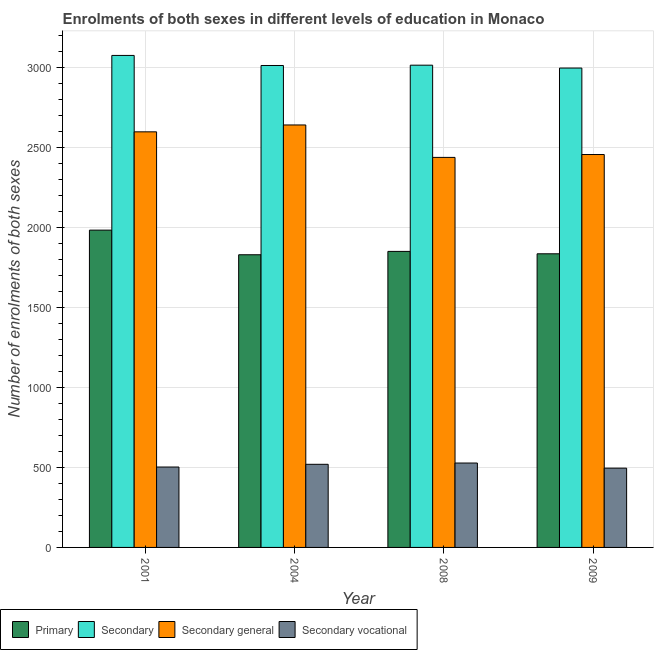How many different coloured bars are there?
Offer a terse response. 4. Are the number of bars per tick equal to the number of legend labels?
Keep it short and to the point. Yes. How many bars are there on the 3rd tick from the left?
Provide a short and direct response. 4. How many bars are there on the 2nd tick from the right?
Make the answer very short. 4. What is the label of the 2nd group of bars from the left?
Make the answer very short. 2004. What is the number of enrolments in secondary education in 2009?
Give a very brief answer. 2999. Across all years, what is the maximum number of enrolments in secondary general education?
Make the answer very short. 2643. Across all years, what is the minimum number of enrolments in secondary vocational education?
Offer a very short reply. 496. In which year was the number of enrolments in secondary general education minimum?
Your answer should be very brief. 2008. What is the total number of enrolments in primary education in the graph?
Offer a very short reply. 7505. What is the difference between the number of enrolments in primary education in 2001 and that in 2008?
Provide a short and direct response. 133. What is the difference between the number of enrolments in secondary vocational education in 2009 and the number of enrolments in secondary general education in 2001?
Give a very brief answer. -7. What is the average number of enrolments in secondary general education per year?
Provide a succinct answer. 2535.25. In the year 2009, what is the difference between the number of enrolments in secondary vocational education and number of enrolments in secondary education?
Offer a terse response. 0. What is the ratio of the number of enrolments in secondary general education in 2004 to that in 2008?
Your response must be concise. 1.08. Is the difference between the number of enrolments in secondary vocational education in 2004 and 2009 greater than the difference between the number of enrolments in secondary education in 2004 and 2009?
Provide a short and direct response. No. What is the difference between the highest and the second highest number of enrolments in primary education?
Provide a succinct answer. 133. What is the difference between the highest and the lowest number of enrolments in secondary vocational education?
Your answer should be very brief. 32. Is the sum of the number of enrolments in secondary vocational education in 2008 and 2009 greater than the maximum number of enrolments in primary education across all years?
Your response must be concise. Yes. What does the 1st bar from the left in 2004 represents?
Your answer should be compact. Primary. What does the 2nd bar from the right in 2001 represents?
Keep it short and to the point. Secondary general. Is it the case that in every year, the sum of the number of enrolments in primary education and number of enrolments in secondary education is greater than the number of enrolments in secondary general education?
Offer a very short reply. Yes. Are all the bars in the graph horizontal?
Make the answer very short. No. How many years are there in the graph?
Offer a very short reply. 4. What is the difference between two consecutive major ticks on the Y-axis?
Keep it short and to the point. 500. Does the graph contain any zero values?
Your answer should be compact. No. What is the title of the graph?
Offer a very short reply. Enrolments of both sexes in different levels of education in Monaco. What is the label or title of the X-axis?
Your response must be concise. Year. What is the label or title of the Y-axis?
Offer a very short reply. Number of enrolments of both sexes. What is the Number of enrolments of both sexes in Primary in 2001?
Provide a short and direct response. 1985. What is the Number of enrolments of both sexes of Secondary in 2001?
Keep it short and to the point. 3078. What is the Number of enrolments of both sexes of Secondary general in 2001?
Offer a terse response. 2600. What is the Number of enrolments of both sexes of Secondary vocational in 2001?
Make the answer very short. 503. What is the Number of enrolments of both sexes of Primary in 2004?
Keep it short and to the point. 1831. What is the Number of enrolments of both sexes of Secondary in 2004?
Offer a very short reply. 3015. What is the Number of enrolments of both sexes of Secondary general in 2004?
Keep it short and to the point. 2643. What is the Number of enrolments of both sexes of Secondary vocational in 2004?
Make the answer very short. 520. What is the Number of enrolments of both sexes of Primary in 2008?
Keep it short and to the point. 1852. What is the Number of enrolments of both sexes in Secondary in 2008?
Your response must be concise. 3017. What is the Number of enrolments of both sexes of Secondary general in 2008?
Ensure brevity in your answer.  2440. What is the Number of enrolments of both sexes of Secondary vocational in 2008?
Your answer should be compact. 528. What is the Number of enrolments of both sexes of Primary in 2009?
Give a very brief answer. 1837. What is the Number of enrolments of both sexes in Secondary in 2009?
Provide a succinct answer. 2999. What is the Number of enrolments of both sexes in Secondary general in 2009?
Your answer should be very brief. 2458. What is the Number of enrolments of both sexes in Secondary vocational in 2009?
Offer a very short reply. 496. Across all years, what is the maximum Number of enrolments of both sexes in Primary?
Ensure brevity in your answer.  1985. Across all years, what is the maximum Number of enrolments of both sexes of Secondary?
Make the answer very short. 3078. Across all years, what is the maximum Number of enrolments of both sexes of Secondary general?
Your response must be concise. 2643. Across all years, what is the maximum Number of enrolments of both sexes in Secondary vocational?
Provide a short and direct response. 528. Across all years, what is the minimum Number of enrolments of both sexes of Primary?
Keep it short and to the point. 1831. Across all years, what is the minimum Number of enrolments of both sexes in Secondary?
Offer a very short reply. 2999. Across all years, what is the minimum Number of enrolments of both sexes of Secondary general?
Give a very brief answer. 2440. Across all years, what is the minimum Number of enrolments of both sexes in Secondary vocational?
Ensure brevity in your answer.  496. What is the total Number of enrolments of both sexes in Primary in the graph?
Make the answer very short. 7505. What is the total Number of enrolments of both sexes of Secondary in the graph?
Provide a short and direct response. 1.21e+04. What is the total Number of enrolments of both sexes of Secondary general in the graph?
Offer a terse response. 1.01e+04. What is the total Number of enrolments of both sexes of Secondary vocational in the graph?
Make the answer very short. 2047. What is the difference between the Number of enrolments of both sexes of Primary in 2001 and that in 2004?
Your answer should be very brief. 154. What is the difference between the Number of enrolments of both sexes in Secondary general in 2001 and that in 2004?
Your response must be concise. -43. What is the difference between the Number of enrolments of both sexes in Primary in 2001 and that in 2008?
Offer a terse response. 133. What is the difference between the Number of enrolments of both sexes of Secondary general in 2001 and that in 2008?
Give a very brief answer. 160. What is the difference between the Number of enrolments of both sexes of Secondary vocational in 2001 and that in 2008?
Your answer should be very brief. -25. What is the difference between the Number of enrolments of both sexes of Primary in 2001 and that in 2009?
Give a very brief answer. 148. What is the difference between the Number of enrolments of both sexes in Secondary in 2001 and that in 2009?
Offer a very short reply. 79. What is the difference between the Number of enrolments of both sexes of Secondary general in 2001 and that in 2009?
Keep it short and to the point. 142. What is the difference between the Number of enrolments of both sexes of Primary in 2004 and that in 2008?
Keep it short and to the point. -21. What is the difference between the Number of enrolments of both sexes in Secondary in 2004 and that in 2008?
Your answer should be compact. -2. What is the difference between the Number of enrolments of both sexes of Secondary general in 2004 and that in 2008?
Give a very brief answer. 203. What is the difference between the Number of enrolments of both sexes of Secondary in 2004 and that in 2009?
Provide a succinct answer. 16. What is the difference between the Number of enrolments of both sexes of Secondary general in 2004 and that in 2009?
Your answer should be compact. 185. What is the difference between the Number of enrolments of both sexes of Secondary vocational in 2004 and that in 2009?
Ensure brevity in your answer.  24. What is the difference between the Number of enrolments of both sexes of Primary in 2008 and that in 2009?
Make the answer very short. 15. What is the difference between the Number of enrolments of both sexes in Primary in 2001 and the Number of enrolments of both sexes in Secondary in 2004?
Give a very brief answer. -1030. What is the difference between the Number of enrolments of both sexes in Primary in 2001 and the Number of enrolments of both sexes in Secondary general in 2004?
Ensure brevity in your answer.  -658. What is the difference between the Number of enrolments of both sexes of Primary in 2001 and the Number of enrolments of both sexes of Secondary vocational in 2004?
Give a very brief answer. 1465. What is the difference between the Number of enrolments of both sexes in Secondary in 2001 and the Number of enrolments of both sexes in Secondary general in 2004?
Provide a short and direct response. 435. What is the difference between the Number of enrolments of both sexes of Secondary in 2001 and the Number of enrolments of both sexes of Secondary vocational in 2004?
Ensure brevity in your answer.  2558. What is the difference between the Number of enrolments of both sexes in Secondary general in 2001 and the Number of enrolments of both sexes in Secondary vocational in 2004?
Ensure brevity in your answer.  2080. What is the difference between the Number of enrolments of both sexes in Primary in 2001 and the Number of enrolments of both sexes in Secondary in 2008?
Your response must be concise. -1032. What is the difference between the Number of enrolments of both sexes in Primary in 2001 and the Number of enrolments of both sexes in Secondary general in 2008?
Provide a short and direct response. -455. What is the difference between the Number of enrolments of both sexes of Primary in 2001 and the Number of enrolments of both sexes of Secondary vocational in 2008?
Offer a very short reply. 1457. What is the difference between the Number of enrolments of both sexes in Secondary in 2001 and the Number of enrolments of both sexes in Secondary general in 2008?
Offer a terse response. 638. What is the difference between the Number of enrolments of both sexes in Secondary in 2001 and the Number of enrolments of both sexes in Secondary vocational in 2008?
Your answer should be compact. 2550. What is the difference between the Number of enrolments of both sexes of Secondary general in 2001 and the Number of enrolments of both sexes of Secondary vocational in 2008?
Your answer should be very brief. 2072. What is the difference between the Number of enrolments of both sexes of Primary in 2001 and the Number of enrolments of both sexes of Secondary in 2009?
Your answer should be compact. -1014. What is the difference between the Number of enrolments of both sexes of Primary in 2001 and the Number of enrolments of both sexes of Secondary general in 2009?
Keep it short and to the point. -473. What is the difference between the Number of enrolments of both sexes of Primary in 2001 and the Number of enrolments of both sexes of Secondary vocational in 2009?
Provide a short and direct response. 1489. What is the difference between the Number of enrolments of both sexes in Secondary in 2001 and the Number of enrolments of both sexes in Secondary general in 2009?
Offer a very short reply. 620. What is the difference between the Number of enrolments of both sexes of Secondary in 2001 and the Number of enrolments of both sexes of Secondary vocational in 2009?
Offer a very short reply. 2582. What is the difference between the Number of enrolments of both sexes in Secondary general in 2001 and the Number of enrolments of both sexes in Secondary vocational in 2009?
Keep it short and to the point. 2104. What is the difference between the Number of enrolments of both sexes of Primary in 2004 and the Number of enrolments of both sexes of Secondary in 2008?
Your answer should be compact. -1186. What is the difference between the Number of enrolments of both sexes of Primary in 2004 and the Number of enrolments of both sexes of Secondary general in 2008?
Your answer should be compact. -609. What is the difference between the Number of enrolments of both sexes in Primary in 2004 and the Number of enrolments of both sexes in Secondary vocational in 2008?
Offer a terse response. 1303. What is the difference between the Number of enrolments of both sexes in Secondary in 2004 and the Number of enrolments of both sexes in Secondary general in 2008?
Ensure brevity in your answer.  575. What is the difference between the Number of enrolments of both sexes of Secondary in 2004 and the Number of enrolments of both sexes of Secondary vocational in 2008?
Offer a terse response. 2487. What is the difference between the Number of enrolments of both sexes in Secondary general in 2004 and the Number of enrolments of both sexes in Secondary vocational in 2008?
Your response must be concise. 2115. What is the difference between the Number of enrolments of both sexes in Primary in 2004 and the Number of enrolments of both sexes in Secondary in 2009?
Provide a short and direct response. -1168. What is the difference between the Number of enrolments of both sexes in Primary in 2004 and the Number of enrolments of both sexes in Secondary general in 2009?
Offer a very short reply. -627. What is the difference between the Number of enrolments of both sexes of Primary in 2004 and the Number of enrolments of both sexes of Secondary vocational in 2009?
Give a very brief answer. 1335. What is the difference between the Number of enrolments of both sexes in Secondary in 2004 and the Number of enrolments of both sexes in Secondary general in 2009?
Ensure brevity in your answer.  557. What is the difference between the Number of enrolments of both sexes in Secondary in 2004 and the Number of enrolments of both sexes in Secondary vocational in 2009?
Keep it short and to the point. 2519. What is the difference between the Number of enrolments of both sexes of Secondary general in 2004 and the Number of enrolments of both sexes of Secondary vocational in 2009?
Offer a very short reply. 2147. What is the difference between the Number of enrolments of both sexes in Primary in 2008 and the Number of enrolments of both sexes in Secondary in 2009?
Your answer should be compact. -1147. What is the difference between the Number of enrolments of both sexes of Primary in 2008 and the Number of enrolments of both sexes of Secondary general in 2009?
Offer a terse response. -606. What is the difference between the Number of enrolments of both sexes in Primary in 2008 and the Number of enrolments of both sexes in Secondary vocational in 2009?
Provide a succinct answer. 1356. What is the difference between the Number of enrolments of both sexes in Secondary in 2008 and the Number of enrolments of both sexes in Secondary general in 2009?
Provide a short and direct response. 559. What is the difference between the Number of enrolments of both sexes of Secondary in 2008 and the Number of enrolments of both sexes of Secondary vocational in 2009?
Offer a very short reply. 2521. What is the difference between the Number of enrolments of both sexes in Secondary general in 2008 and the Number of enrolments of both sexes in Secondary vocational in 2009?
Offer a very short reply. 1944. What is the average Number of enrolments of both sexes in Primary per year?
Offer a very short reply. 1876.25. What is the average Number of enrolments of both sexes in Secondary per year?
Offer a terse response. 3027.25. What is the average Number of enrolments of both sexes in Secondary general per year?
Provide a short and direct response. 2535.25. What is the average Number of enrolments of both sexes of Secondary vocational per year?
Give a very brief answer. 511.75. In the year 2001, what is the difference between the Number of enrolments of both sexes of Primary and Number of enrolments of both sexes of Secondary?
Provide a short and direct response. -1093. In the year 2001, what is the difference between the Number of enrolments of both sexes in Primary and Number of enrolments of both sexes in Secondary general?
Your response must be concise. -615. In the year 2001, what is the difference between the Number of enrolments of both sexes of Primary and Number of enrolments of both sexes of Secondary vocational?
Keep it short and to the point. 1482. In the year 2001, what is the difference between the Number of enrolments of both sexes of Secondary and Number of enrolments of both sexes of Secondary general?
Offer a terse response. 478. In the year 2001, what is the difference between the Number of enrolments of both sexes of Secondary and Number of enrolments of both sexes of Secondary vocational?
Offer a very short reply. 2575. In the year 2001, what is the difference between the Number of enrolments of both sexes of Secondary general and Number of enrolments of both sexes of Secondary vocational?
Keep it short and to the point. 2097. In the year 2004, what is the difference between the Number of enrolments of both sexes in Primary and Number of enrolments of both sexes in Secondary?
Give a very brief answer. -1184. In the year 2004, what is the difference between the Number of enrolments of both sexes in Primary and Number of enrolments of both sexes in Secondary general?
Provide a short and direct response. -812. In the year 2004, what is the difference between the Number of enrolments of both sexes of Primary and Number of enrolments of both sexes of Secondary vocational?
Ensure brevity in your answer.  1311. In the year 2004, what is the difference between the Number of enrolments of both sexes in Secondary and Number of enrolments of both sexes in Secondary general?
Offer a very short reply. 372. In the year 2004, what is the difference between the Number of enrolments of both sexes of Secondary and Number of enrolments of both sexes of Secondary vocational?
Your answer should be very brief. 2495. In the year 2004, what is the difference between the Number of enrolments of both sexes of Secondary general and Number of enrolments of both sexes of Secondary vocational?
Provide a succinct answer. 2123. In the year 2008, what is the difference between the Number of enrolments of both sexes of Primary and Number of enrolments of both sexes of Secondary?
Give a very brief answer. -1165. In the year 2008, what is the difference between the Number of enrolments of both sexes in Primary and Number of enrolments of both sexes in Secondary general?
Ensure brevity in your answer.  -588. In the year 2008, what is the difference between the Number of enrolments of both sexes of Primary and Number of enrolments of both sexes of Secondary vocational?
Provide a succinct answer. 1324. In the year 2008, what is the difference between the Number of enrolments of both sexes in Secondary and Number of enrolments of both sexes in Secondary general?
Keep it short and to the point. 577. In the year 2008, what is the difference between the Number of enrolments of both sexes of Secondary and Number of enrolments of both sexes of Secondary vocational?
Ensure brevity in your answer.  2489. In the year 2008, what is the difference between the Number of enrolments of both sexes of Secondary general and Number of enrolments of both sexes of Secondary vocational?
Your answer should be very brief. 1912. In the year 2009, what is the difference between the Number of enrolments of both sexes of Primary and Number of enrolments of both sexes of Secondary?
Offer a very short reply. -1162. In the year 2009, what is the difference between the Number of enrolments of both sexes in Primary and Number of enrolments of both sexes in Secondary general?
Provide a succinct answer. -621. In the year 2009, what is the difference between the Number of enrolments of both sexes of Primary and Number of enrolments of both sexes of Secondary vocational?
Your response must be concise. 1341. In the year 2009, what is the difference between the Number of enrolments of both sexes in Secondary and Number of enrolments of both sexes in Secondary general?
Offer a terse response. 541. In the year 2009, what is the difference between the Number of enrolments of both sexes of Secondary and Number of enrolments of both sexes of Secondary vocational?
Offer a terse response. 2503. In the year 2009, what is the difference between the Number of enrolments of both sexes of Secondary general and Number of enrolments of both sexes of Secondary vocational?
Your answer should be compact. 1962. What is the ratio of the Number of enrolments of both sexes in Primary in 2001 to that in 2004?
Ensure brevity in your answer.  1.08. What is the ratio of the Number of enrolments of both sexes of Secondary in 2001 to that in 2004?
Offer a terse response. 1.02. What is the ratio of the Number of enrolments of both sexes in Secondary general in 2001 to that in 2004?
Your answer should be very brief. 0.98. What is the ratio of the Number of enrolments of both sexes of Secondary vocational in 2001 to that in 2004?
Your answer should be very brief. 0.97. What is the ratio of the Number of enrolments of both sexes of Primary in 2001 to that in 2008?
Provide a short and direct response. 1.07. What is the ratio of the Number of enrolments of both sexes of Secondary in 2001 to that in 2008?
Give a very brief answer. 1.02. What is the ratio of the Number of enrolments of both sexes of Secondary general in 2001 to that in 2008?
Provide a succinct answer. 1.07. What is the ratio of the Number of enrolments of both sexes of Secondary vocational in 2001 to that in 2008?
Give a very brief answer. 0.95. What is the ratio of the Number of enrolments of both sexes of Primary in 2001 to that in 2009?
Ensure brevity in your answer.  1.08. What is the ratio of the Number of enrolments of both sexes in Secondary in 2001 to that in 2009?
Ensure brevity in your answer.  1.03. What is the ratio of the Number of enrolments of both sexes of Secondary general in 2001 to that in 2009?
Provide a short and direct response. 1.06. What is the ratio of the Number of enrolments of both sexes of Secondary vocational in 2001 to that in 2009?
Provide a succinct answer. 1.01. What is the ratio of the Number of enrolments of both sexes in Primary in 2004 to that in 2008?
Offer a terse response. 0.99. What is the ratio of the Number of enrolments of both sexes of Secondary in 2004 to that in 2008?
Your response must be concise. 1. What is the ratio of the Number of enrolments of both sexes of Secondary general in 2004 to that in 2008?
Your answer should be very brief. 1.08. What is the ratio of the Number of enrolments of both sexes of Secondary in 2004 to that in 2009?
Provide a short and direct response. 1.01. What is the ratio of the Number of enrolments of both sexes of Secondary general in 2004 to that in 2009?
Your response must be concise. 1.08. What is the ratio of the Number of enrolments of both sexes in Secondary vocational in 2004 to that in 2009?
Make the answer very short. 1.05. What is the ratio of the Number of enrolments of both sexes of Primary in 2008 to that in 2009?
Provide a succinct answer. 1.01. What is the ratio of the Number of enrolments of both sexes in Secondary in 2008 to that in 2009?
Provide a short and direct response. 1.01. What is the ratio of the Number of enrolments of both sexes in Secondary general in 2008 to that in 2009?
Offer a terse response. 0.99. What is the ratio of the Number of enrolments of both sexes of Secondary vocational in 2008 to that in 2009?
Offer a very short reply. 1.06. What is the difference between the highest and the second highest Number of enrolments of both sexes in Primary?
Your response must be concise. 133. What is the difference between the highest and the lowest Number of enrolments of both sexes in Primary?
Make the answer very short. 154. What is the difference between the highest and the lowest Number of enrolments of both sexes in Secondary?
Keep it short and to the point. 79. What is the difference between the highest and the lowest Number of enrolments of both sexes in Secondary general?
Your answer should be compact. 203. What is the difference between the highest and the lowest Number of enrolments of both sexes in Secondary vocational?
Offer a very short reply. 32. 